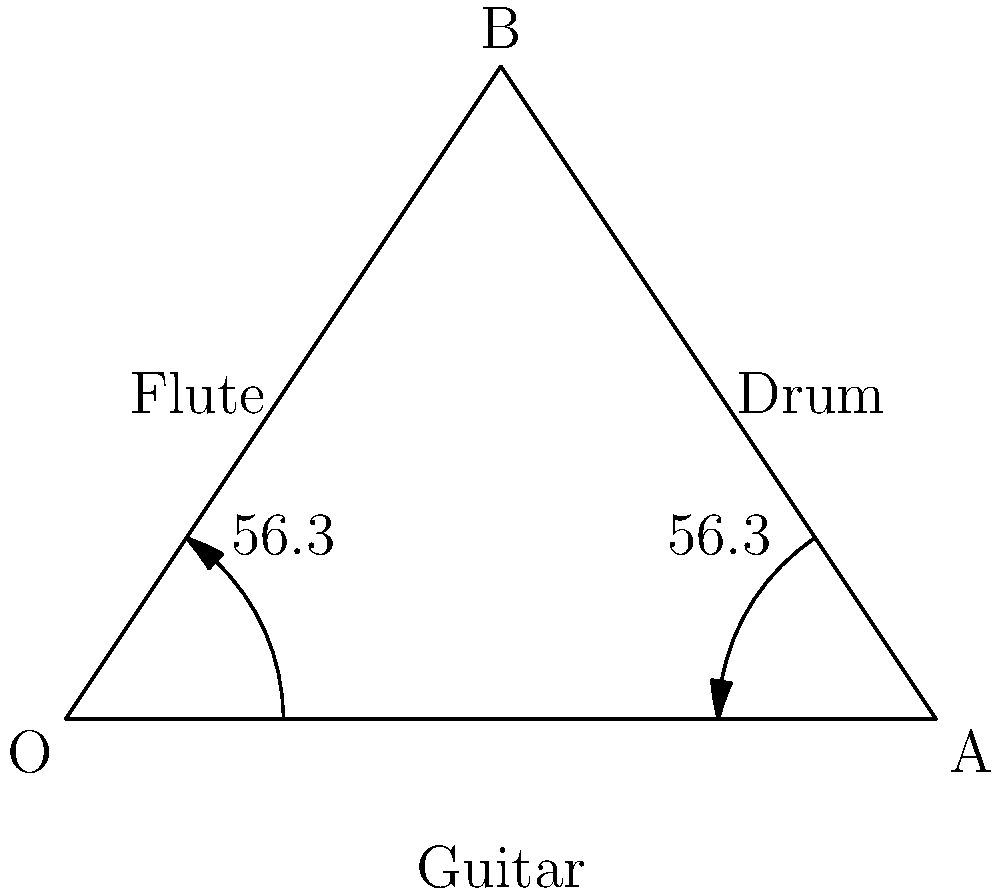During an outdoor performance, you're experimenting with the acoustic properties of different folk instruments. A guitar is placed at point O, a flute at point A, and a drum at point B, forming a triangle. The angle of the sound waves from both the guitar and flute to the drum is 56.3°. If the distance between the guitar and flute is 4 meters, what is the height of the triangle formed by these three instruments? Let's approach this step-by-step:

1) We have an isosceles triangle OAB, where OB = AB, as the angles at O and A are equal (56.3°).

2) The base of the triangle (OA) is 4 meters.

3) We need to find the height of the triangle, which is the perpendicular line from point B to OA.

4) In an isosceles triangle, this height bisects the base. So, we can focus on the right triangle formed by this height and half of the base.

5) Let's call the height h. Half of the base is 2 meters.

6) In this right triangle, we know one angle (56.3°) and the adjacent side (2 meters).

7) We can use the tangent function:

   $$\tan(56.3°) = \frac{h}{2}$$

8) Solving for h:

   $$h = 2 \tan(56.3°)$$

9) Using a calculator (or trigonometric tables):

   $$h = 2 * 1.4945 = 2.989 \text{ meters}$$

10) Rounding to two decimal places, the height is 2.99 meters.
Answer: 2.99 meters 